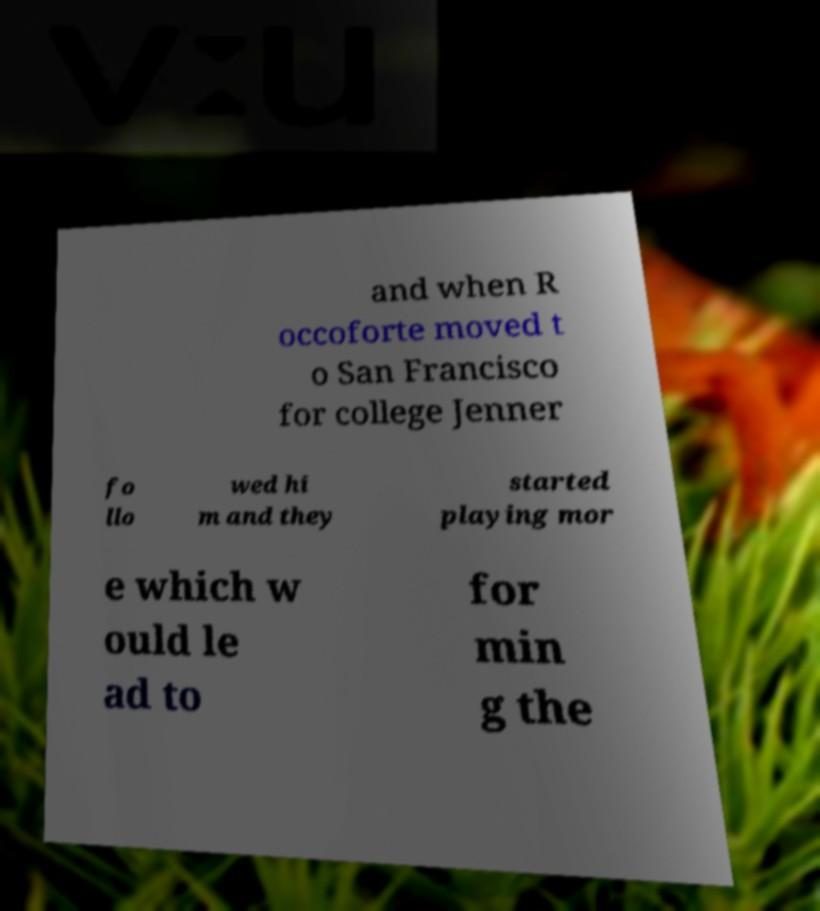Please read and relay the text visible in this image. What does it say? and when R occoforte moved t o San Francisco for college Jenner fo llo wed hi m and they started playing mor e which w ould le ad to for min g the 